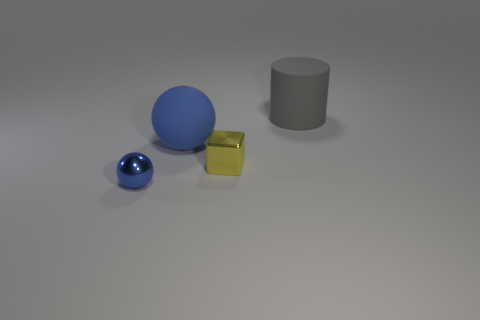Add 1 large blue rubber things. How many objects exist? 5 Subtract all cubes. How many objects are left? 3 Subtract all blue metallic cylinders. Subtract all tiny yellow things. How many objects are left? 3 Add 2 blue objects. How many blue objects are left? 4 Add 4 brown matte balls. How many brown matte balls exist? 4 Subtract 0 green spheres. How many objects are left? 4 